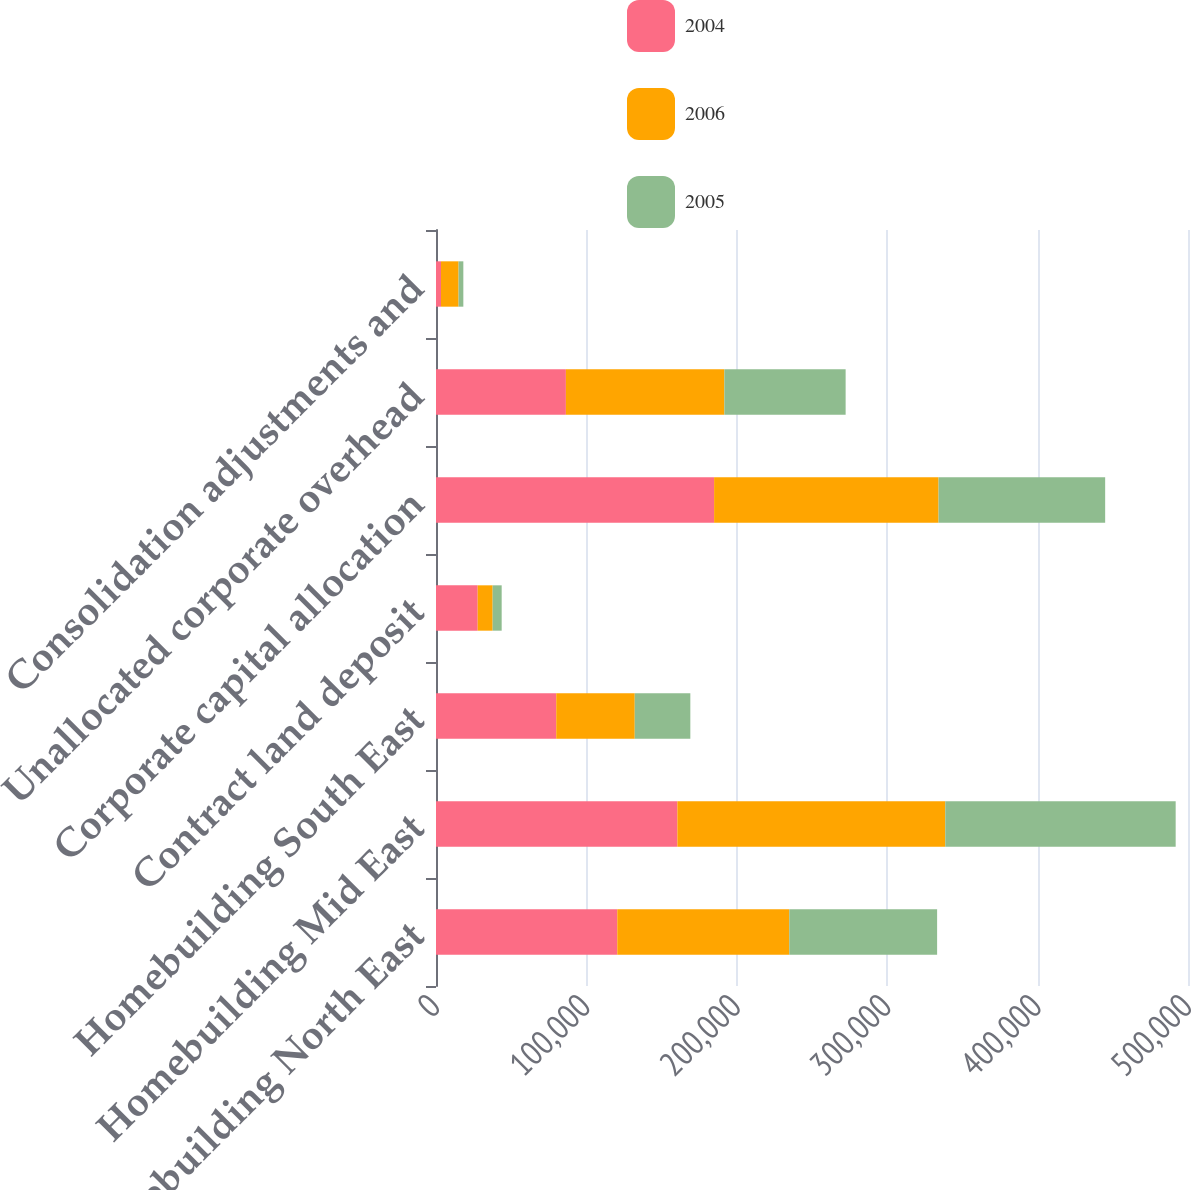Convert chart. <chart><loc_0><loc_0><loc_500><loc_500><stacked_bar_chart><ecel><fcel>Homebuilding North East<fcel>Homebuilding Mid East<fcel>Homebuilding South East<fcel>Contract land deposit<fcel>Corporate capital allocation<fcel>Unallocated corporate overhead<fcel>Consolidation adjustments and<nl><fcel>2004<fcel>120531<fcel>160494<fcel>79948<fcel>27717<fcel>184908<fcel>86363<fcel>3340<nl><fcel>2006<fcel>114365<fcel>178114<fcel>52199<fcel>9950<fcel>149247<fcel>105364<fcel>11670<nl><fcel>2005<fcel>98291<fcel>153197<fcel>36958<fcel>6000<fcel>110769<fcel>80635<fcel>3168<nl></chart> 